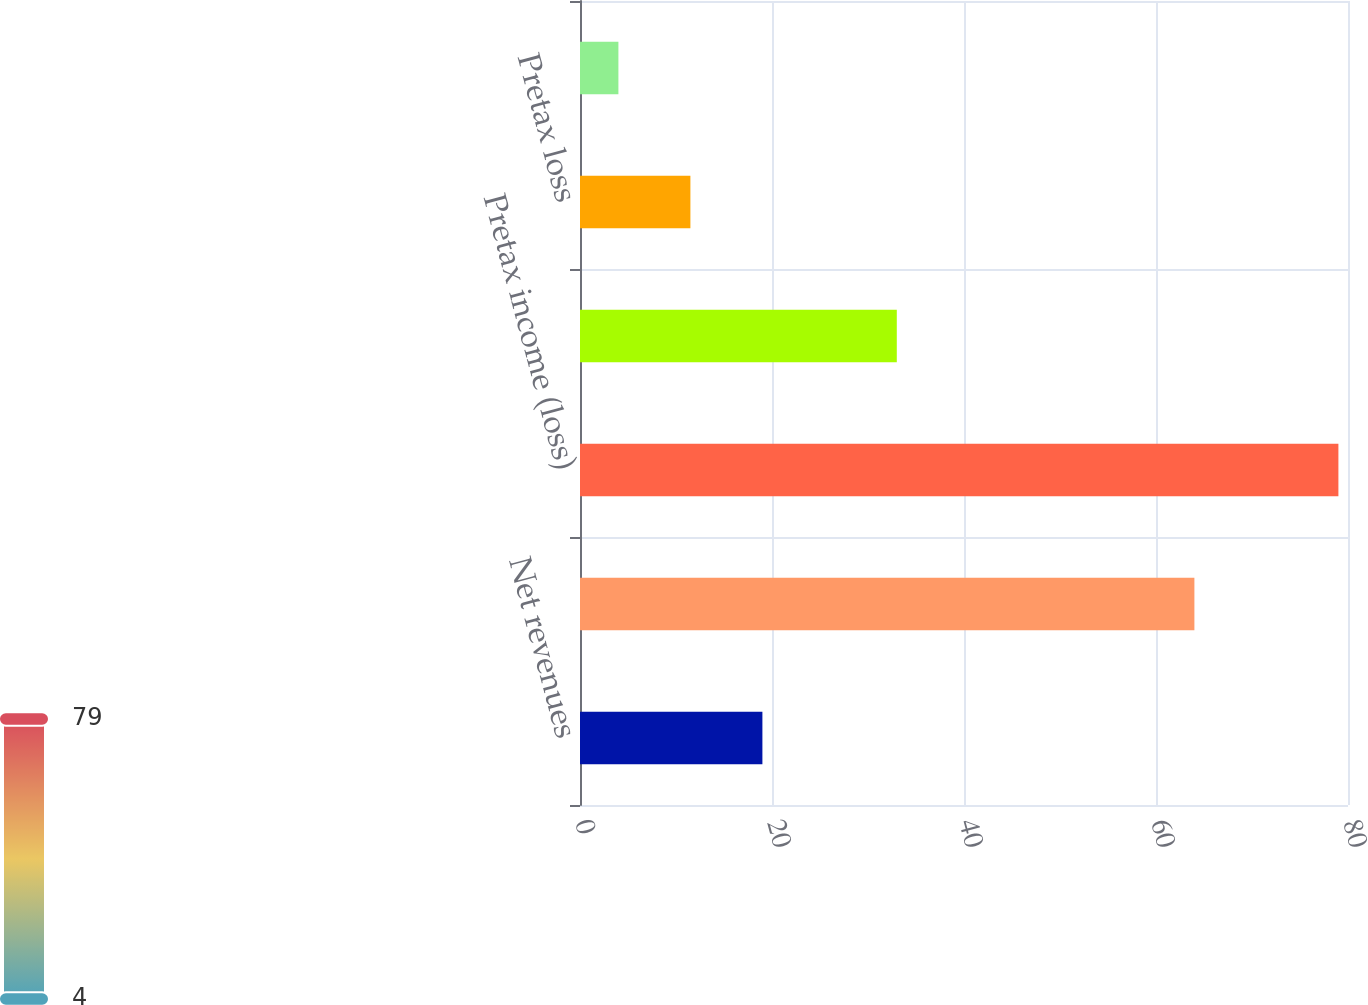Convert chart. <chart><loc_0><loc_0><loc_500><loc_500><bar_chart><fcel>Net revenues<fcel>Expenses<fcel>Pretax income (loss)<fcel>Pretax income<fcel>Pretax loss<fcel>Pretax loss attributable to<nl><fcel>19<fcel>64<fcel>79<fcel>33<fcel>11.5<fcel>4<nl></chart> 